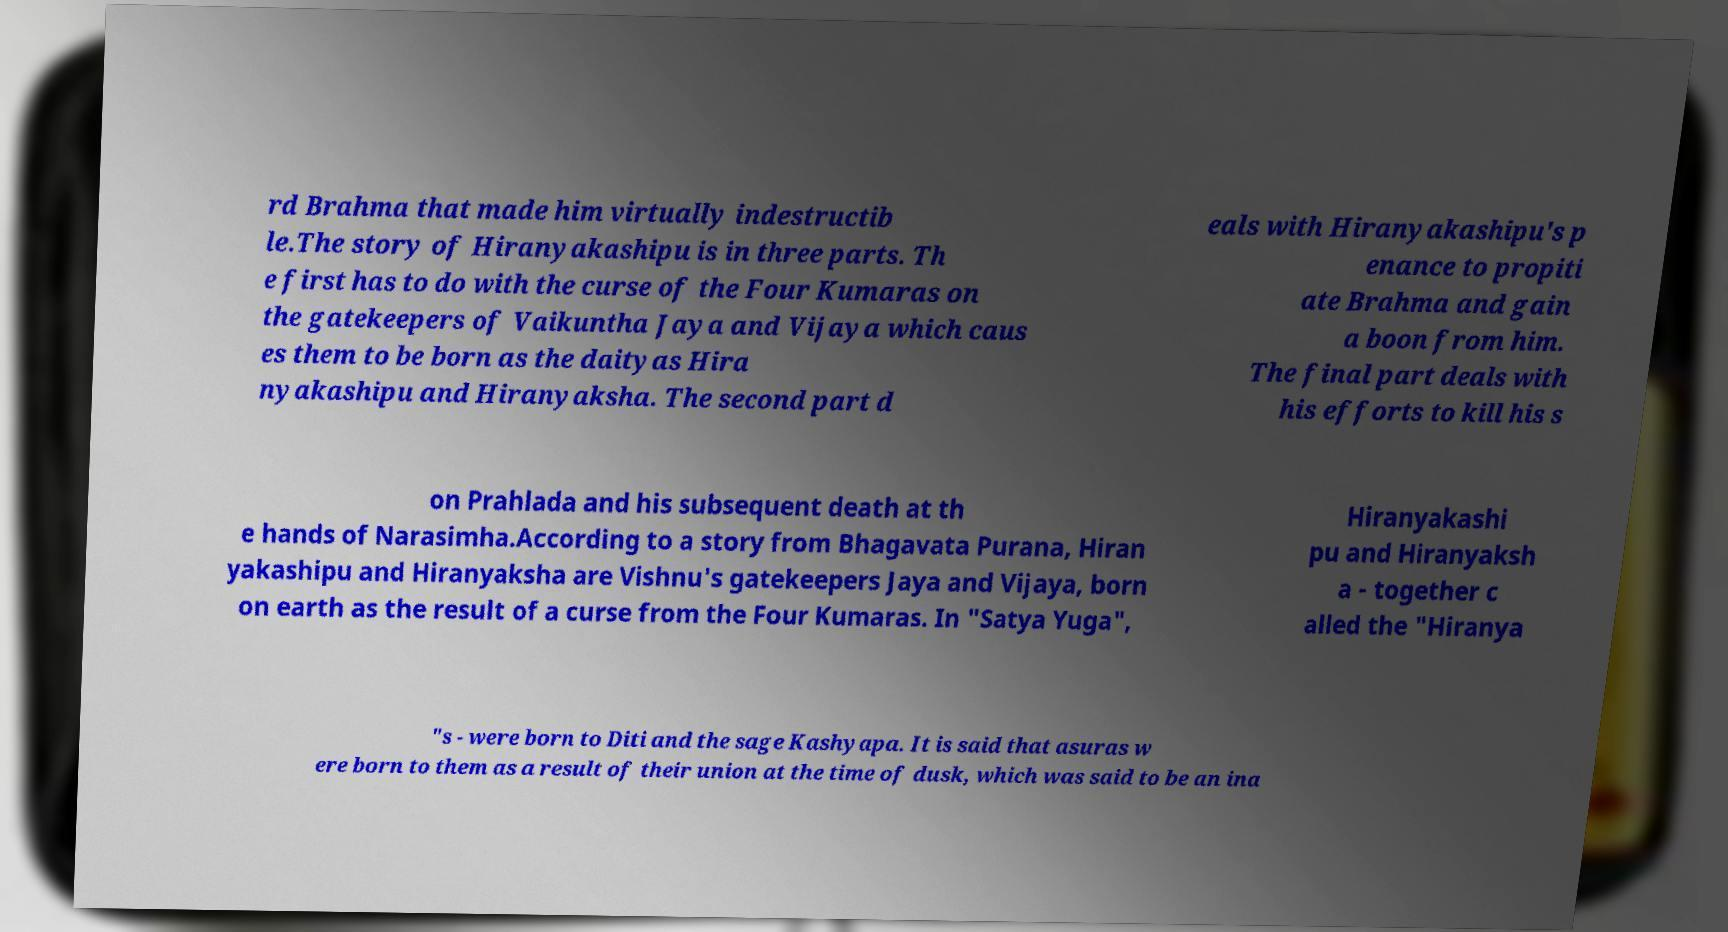Can you accurately transcribe the text from the provided image for me? rd Brahma that made him virtually indestructib le.The story of Hiranyakashipu is in three parts. Th e first has to do with the curse of the Four Kumaras on the gatekeepers of Vaikuntha Jaya and Vijaya which caus es them to be born as the daityas Hira nyakashipu and Hiranyaksha. The second part d eals with Hiranyakashipu's p enance to propiti ate Brahma and gain a boon from him. The final part deals with his efforts to kill his s on Prahlada and his subsequent death at th e hands of Narasimha.According to a story from Bhagavata Purana, Hiran yakashipu and Hiranyaksha are Vishnu's gatekeepers Jaya and Vijaya, born on earth as the result of a curse from the Four Kumaras. In "Satya Yuga", Hiranyakashi pu and Hiranyaksh a - together c alled the "Hiranya "s - were born to Diti and the sage Kashyapa. It is said that asuras w ere born to them as a result of their union at the time of dusk, which was said to be an ina 